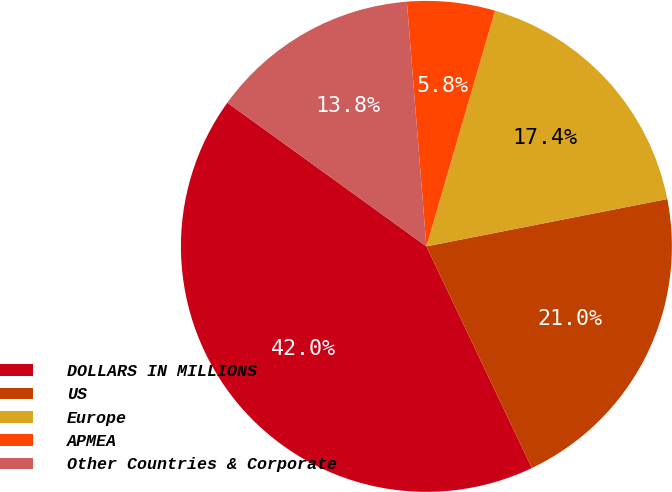<chart> <loc_0><loc_0><loc_500><loc_500><pie_chart><fcel>DOLLARS IN MILLIONS<fcel>US<fcel>Europe<fcel>APMEA<fcel>Other Countries & Corporate<nl><fcel>42.02%<fcel>21.02%<fcel>17.4%<fcel>5.78%<fcel>13.78%<nl></chart> 